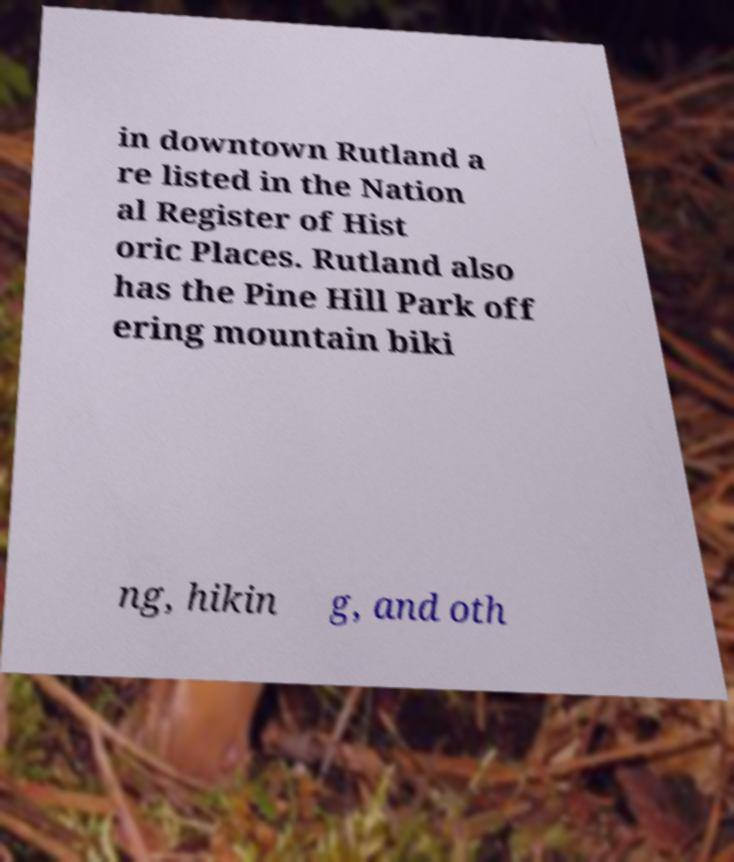Please read and relay the text visible in this image. What does it say? in downtown Rutland a re listed in the Nation al Register of Hist oric Places. Rutland also has the Pine Hill Park off ering mountain biki ng, hikin g, and oth 